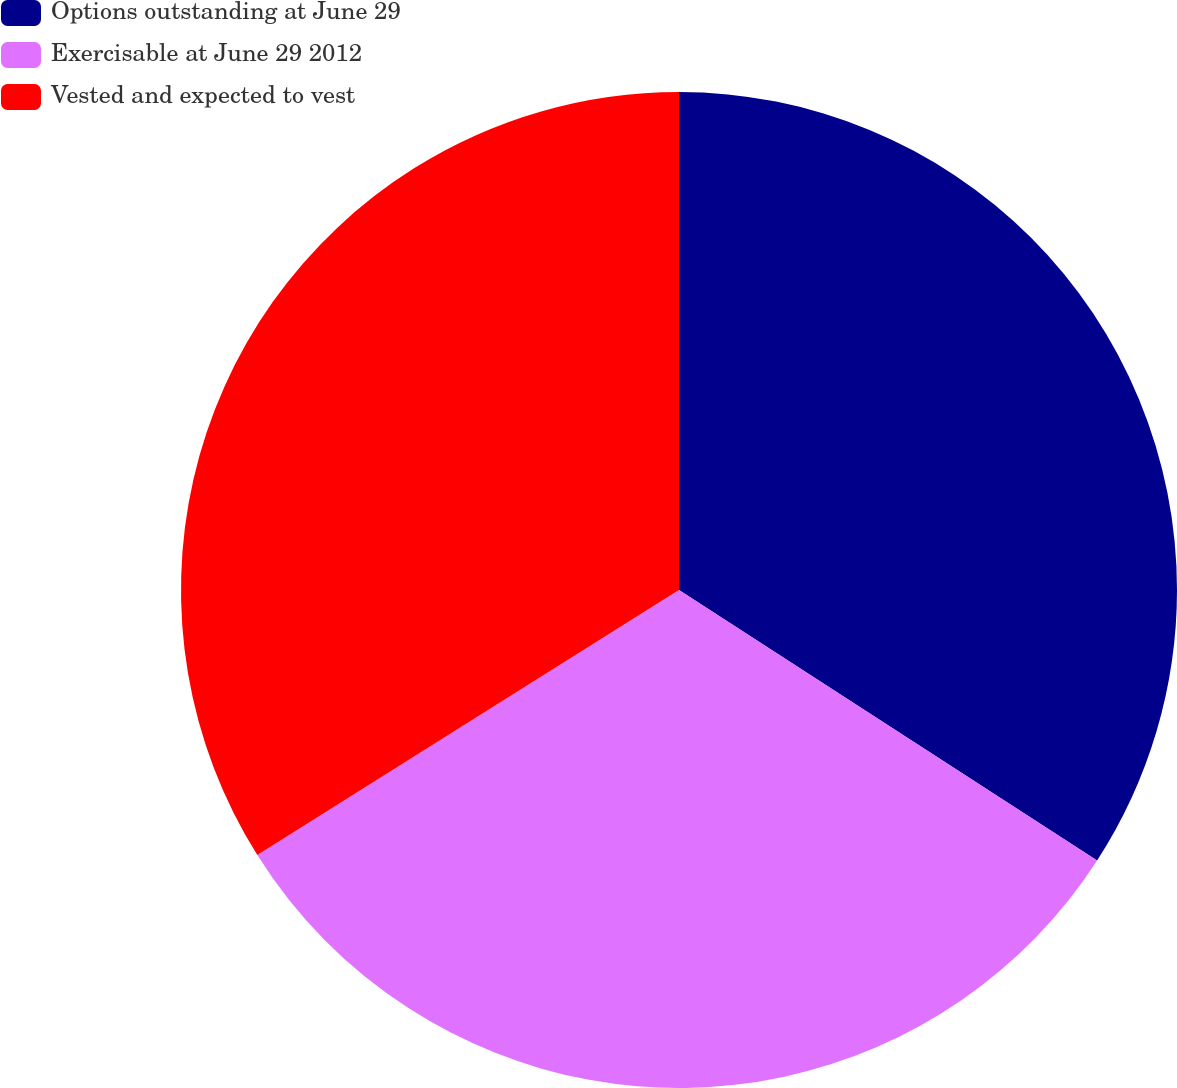Convert chart to OTSL. <chart><loc_0><loc_0><loc_500><loc_500><pie_chart><fcel>Options outstanding at June 29<fcel>Exercisable at June 29 2012<fcel>Vested and expected to vest<nl><fcel>34.14%<fcel>31.93%<fcel>33.93%<nl></chart> 